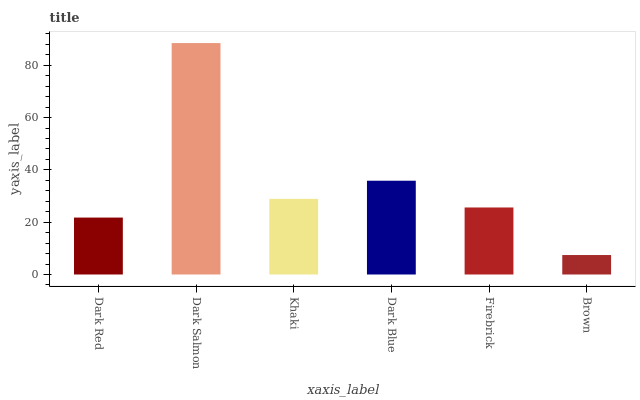Is Khaki the minimum?
Answer yes or no. No. Is Khaki the maximum?
Answer yes or no. No. Is Dark Salmon greater than Khaki?
Answer yes or no. Yes. Is Khaki less than Dark Salmon?
Answer yes or no. Yes. Is Khaki greater than Dark Salmon?
Answer yes or no. No. Is Dark Salmon less than Khaki?
Answer yes or no. No. Is Khaki the high median?
Answer yes or no. Yes. Is Firebrick the low median?
Answer yes or no. Yes. Is Dark Red the high median?
Answer yes or no. No. Is Dark Salmon the low median?
Answer yes or no. No. 